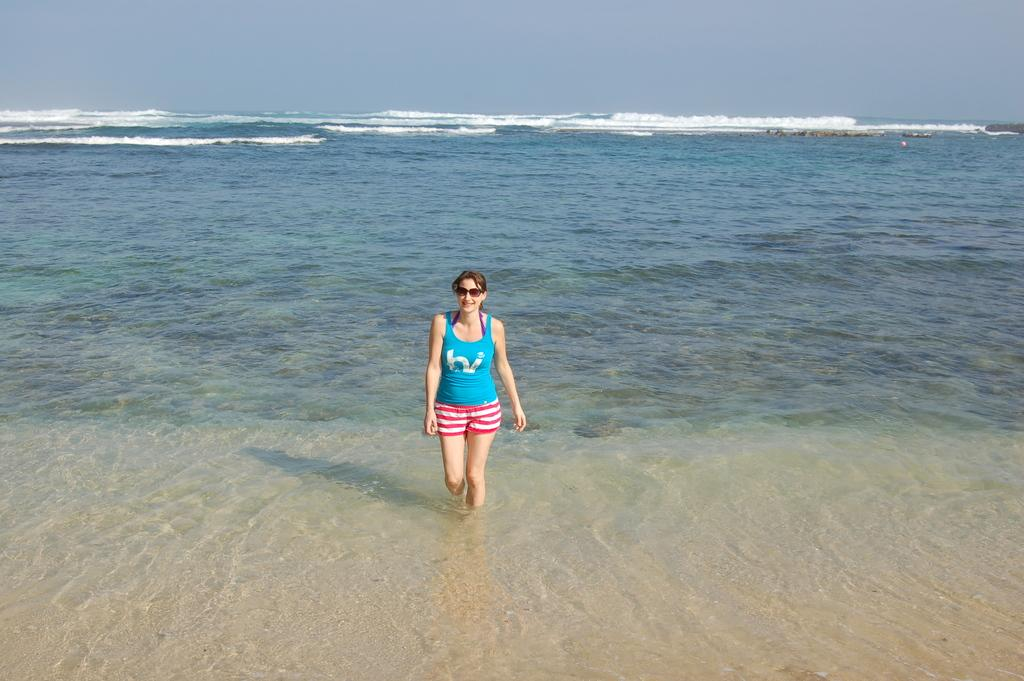What is the main subject of the image? The main subject of the image is a woman. What type of natural feature can be seen in the image? There is a water body in the image. What is visible at the top of the image? The sky is visible at the top of the image. Can you see any animals at the zoo in the image? There is no zoo present in the image, so it is not possible to see any animals there. What type of tail can be seen on the woman in the image? There is no tail visible on the woman in the image. --- Facts: 1. There is a car in the image. 2. The car is parked on the street. 3. There are buildings in the background of the image. 4. The sky is visible at the top of the image. Absurd Topics: parrot, sand, ocean Conversation: What is the main subject of the image? The main subject of the image is a car. Where is the car located in the image? The car is parked on the street. What can be seen in the background of the image? There are buildings in the background of the image. What is visible at the top of the image? The sky is visible at the top of the image. Reasoning: Let's think step by step in order to produce the conversation. We start by identifying the main subject of the image, which is the car. Then, we describe the car's location, which is parked on the street. Next, we mention the background features, which are the buildings. Finally, we acknowledge the presence of the sky at the top of the image. Absurd Question/Answer: Can you see any parrots flying over the ocean in the image? There is no ocean or parrots present in the image; it features a car parked on the street with buildings in the background. What type of sand can be seen on the beach in the image? There is no beach or sand present in the image. 